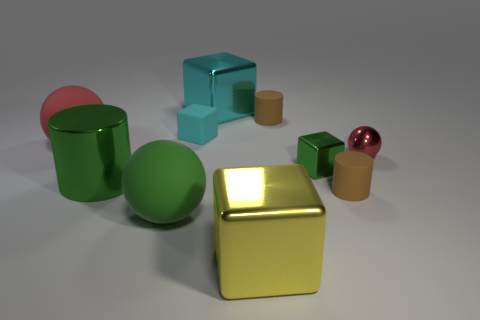What is the main source of light in this scene, and what effect does it have on the objects? The main source of light appears to be coming from the upper right side of the scene, casting soft shadows to the left of the objects. This lighting creates highlights on the shiny surfaces of the objects, particularly noticeable on the metallic cube and cylinder. 